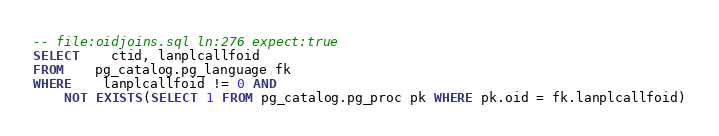<code> <loc_0><loc_0><loc_500><loc_500><_SQL_>-- file:oidjoins.sql ln:276 expect:true
SELECT	ctid, lanplcallfoid
FROM	pg_catalog.pg_language fk
WHERE	lanplcallfoid != 0 AND
	NOT EXISTS(SELECT 1 FROM pg_catalog.pg_proc pk WHERE pk.oid = fk.lanplcallfoid)
</code> 